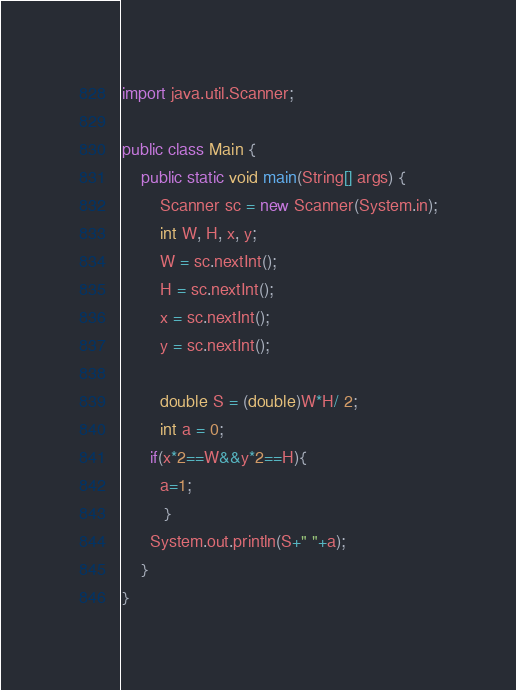Convert code to text. <code><loc_0><loc_0><loc_500><loc_500><_Java_>import java.util.Scanner;

public class Main {
	public static void main(String[] args) {
		Scanner sc = new Scanner(System.in);
		int W, H, x, y;
		W = sc.nextInt();
		H = sc.nextInt();
		x = sc.nextInt();
		y = sc.nextInt();

		double S = (double)W*H/ 2;
		int a = 0;
      if(x*2==W&&y*2==H){
        a=1;
         }
      System.out.println(S+" "+a);
	}
}
</code> 